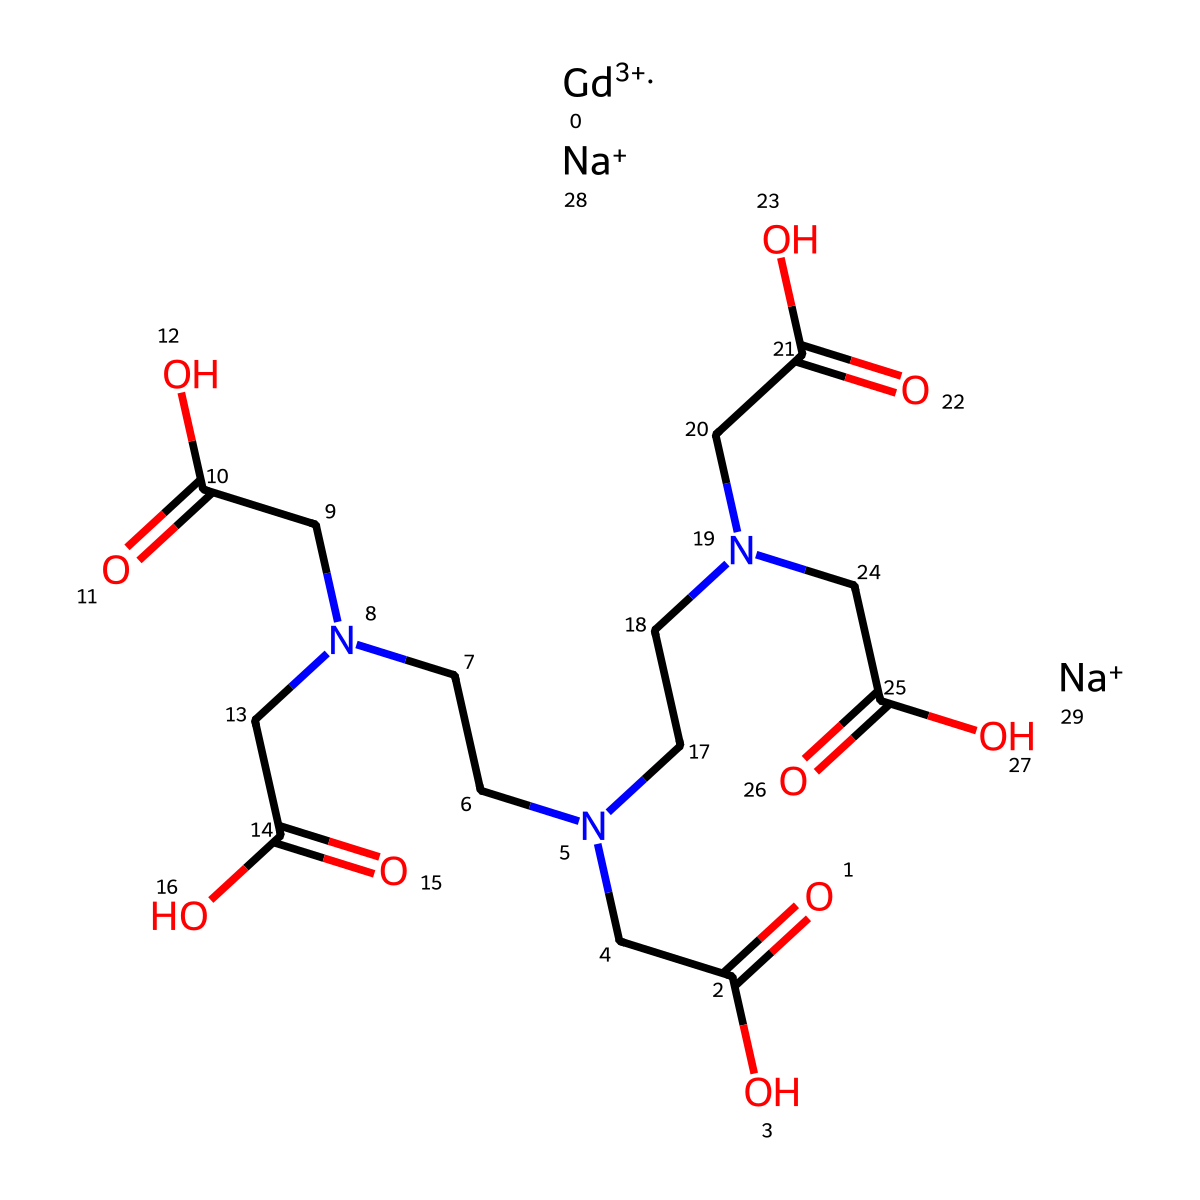What is the central metal ion in this compound? The SMILES representation includes "[Gd+3]", indicating that gadolinium (Gd) is the central metal ion with a +3 charge.
Answer: gadolinium How many nitrogen atoms are present in this chemical structure? By analyzing the SMILES, we see several "N" symbols, specifically three distinct nitrogen atoms shown in the chain of the compound.
Answer: three What is the total number of carboxylic acid functional groups in the molecule? The "CC(=O)O" structure appears multiple times, representing carboxylic acid groups. There are four instances of this group in the compound.
Answer: four What is the overall charge of the molecule? The SMILES shows "[Na+].[Na+]" indicating two sodium ions with a +1 charge each, but there is no indication of an overall negative charge from the molecular structure, leading to an overall neutral charge.
Answer: neutral Which part of the chemical structure contributes to its role as a contrast agent in MRI? The presence of gadolinium, a paramagnetic ion, is responsible for enhancing contrast in MRI due to its unpaired electrons which affect magnetic fields.
Answer: gadolinium 